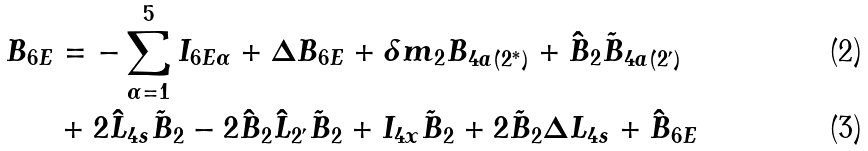<formula> <loc_0><loc_0><loc_500><loc_500>B _ { 6 E } & = - \sum _ { \alpha = 1 } ^ { 5 } I _ { 6 E \alpha } + \Delta B _ { 6 E } + \delta m _ { 2 } B _ { 4 a ( 2 ^ { \ast } ) } + \hat { B } _ { 2 } \tilde { B } _ { 4 a ( 2 ^ { \prime } ) } \\ & + 2 \hat { L } _ { 4 s } \tilde { B } _ { 2 } - 2 \hat { B } _ { 2 } \hat { L } _ { 2 ^ { \prime } } \tilde { B } _ { 2 } + I _ { 4 x } \tilde { B } _ { 2 } + 2 \tilde { B } _ { 2 } \Delta L _ { 4 s } + \hat { B } _ { 6 E }</formula> 